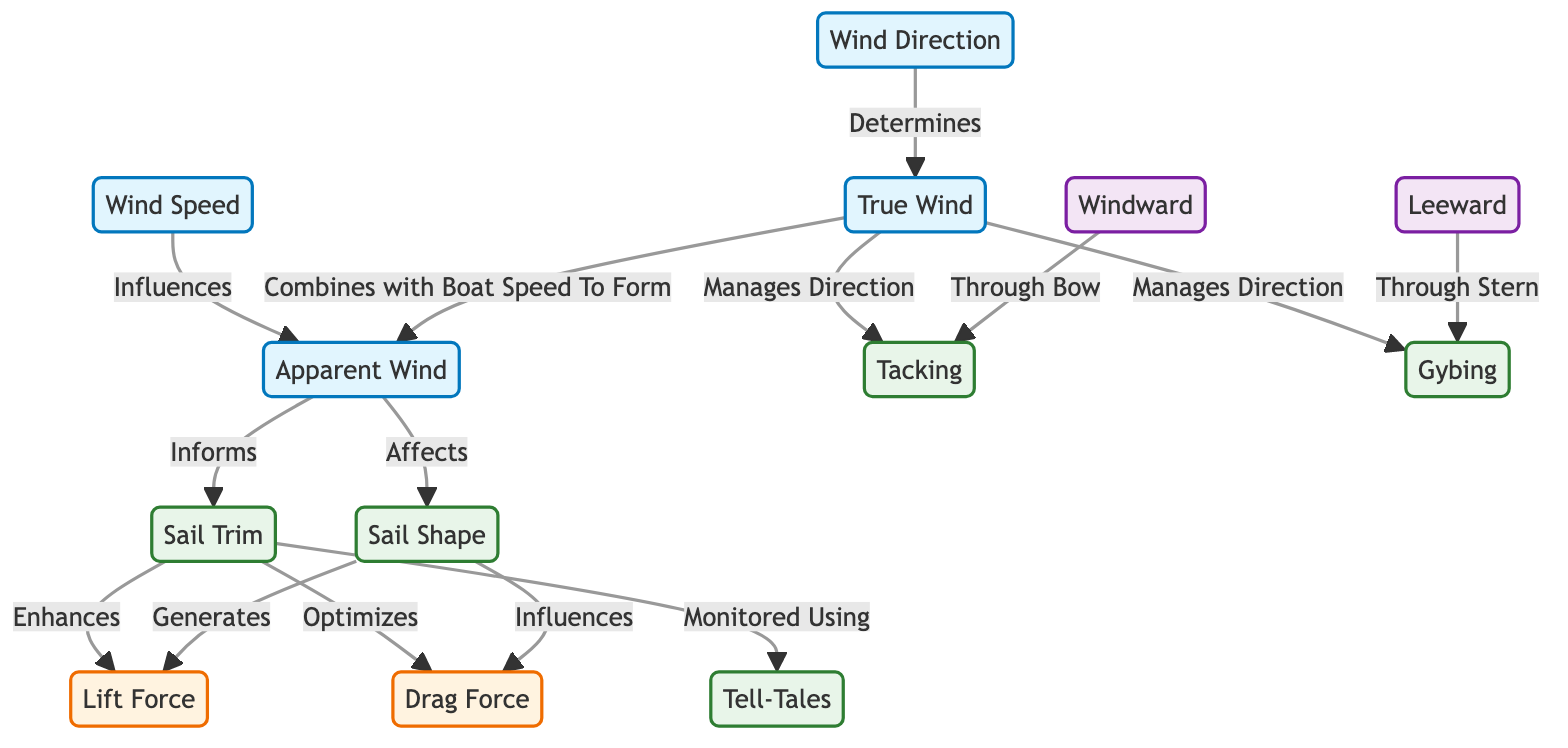What influences apparent wind? According to the diagram, wind speed influences the apparent wind directly. This is indicated by the arrow pointing from the wind speed node to the apparent wind node.
Answer: Wind speed What generates lift force? The diagram shows that lift force is generated by sail shape. This is represented by the arrow leading from the sail shape node to the lift force node.
Answer: Sail shape How does true wind manage direction? The diagram illustrates that true wind manages direction through two actions: tacking and gybing. Both actions are shown to be influenced by true wind, indicated by arrows.
Answer: Tacking and gybing What optimizes drag force? The diagram indicates that drag force is optimized by sail trim, as shown by the direct connection from sail trim to drag force.
Answer: Sail trim Which side of the yacht is tacking through? The diagram specifies that tacking is conducted through the bow of the yacht, as it connects the windward position to the tacking action.
Answer: Bow What informs sail trim? The apparent wind informs sail trim, as indicated by the arrow directing from apparent wind to sail trim in the diagram.
Answer: Apparent wind What affects sail shape? According to the diagram, the apparent wind affects sail shape, illustrated by the arrow pointing from apparent wind to sail shape.
Answer: Apparent wind How many actions are represented in the diagram? The diagram contains four actions: sail trim, tacking, gybing, and sail shape. By counting the relevant nodes in the diagram, we can identify these actions.
Answer: Four actions What role do tell-tales play? The diagram shows that tell-tales are used to monitor sail trim, which is indicated by the arrow linking sail trim to the tell-tales node.
Answer: Monitor sail trim 